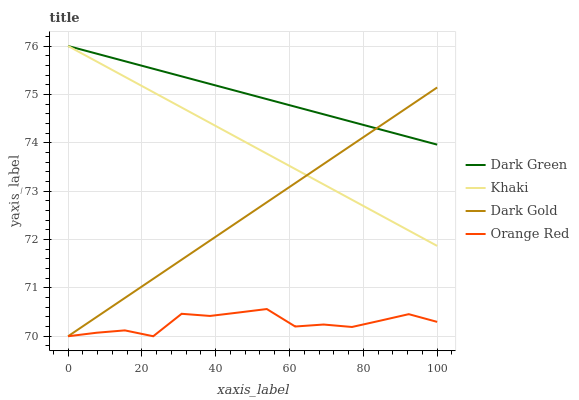Does Orange Red have the minimum area under the curve?
Answer yes or no. Yes. Does Dark Green have the maximum area under the curve?
Answer yes or no. Yes. Does Dark Gold have the minimum area under the curve?
Answer yes or no. No. Does Dark Gold have the maximum area under the curve?
Answer yes or no. No. Is Dark Green the smoothest?
Answer yes or no. Yes. Is Orange Red the roughest?
Answer yes or no. Yes. Is Dark Gold the smoothest?
Answer yes or no. No. Is Dark Gold the roughest?
Answer yes or no. No. Does Orange Red have the lowest value?
Answer yes or no. Yes. Does Dark Green have the lowest value?
Answer yes or no. No. Does Dark Green have the highest value?
Answer yes or no. Yes. Does Dark Gold have the highest value?
Answer yes or no. No. Is Orange Red less than Khaki?
Answer yes or no. Yes. Is Dark Green greater than Orange Red?
Answer yes or no. Yes. Does Dark Gold intersect Orange Red?
Answer yes or no. Yes. Is Dark Gold less than Orange Red?
Answer yes or no. No. Is Dark Gold greater than Orange Red?
Answer yes or no. No. Does Orange Red intersect Khaki?
Answer yes or no. No. 